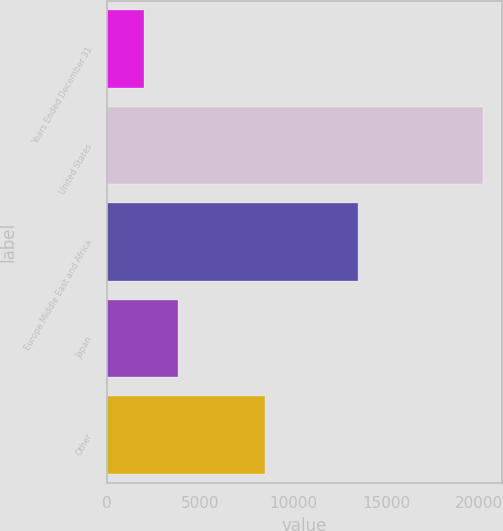Convert chart to OTSL. <chart><loc_0><loc_0><loc_500><loc_500><bar_chart><fcel>Years Ended December 31<fcel>United States<fcel>Europe Middle East and Africa<fcel>Japan<fcel>Other<nl><fcel>2010<fcel>20226<fcel>13497<fcel>3831.6<fcel>8496<nl></chart> 